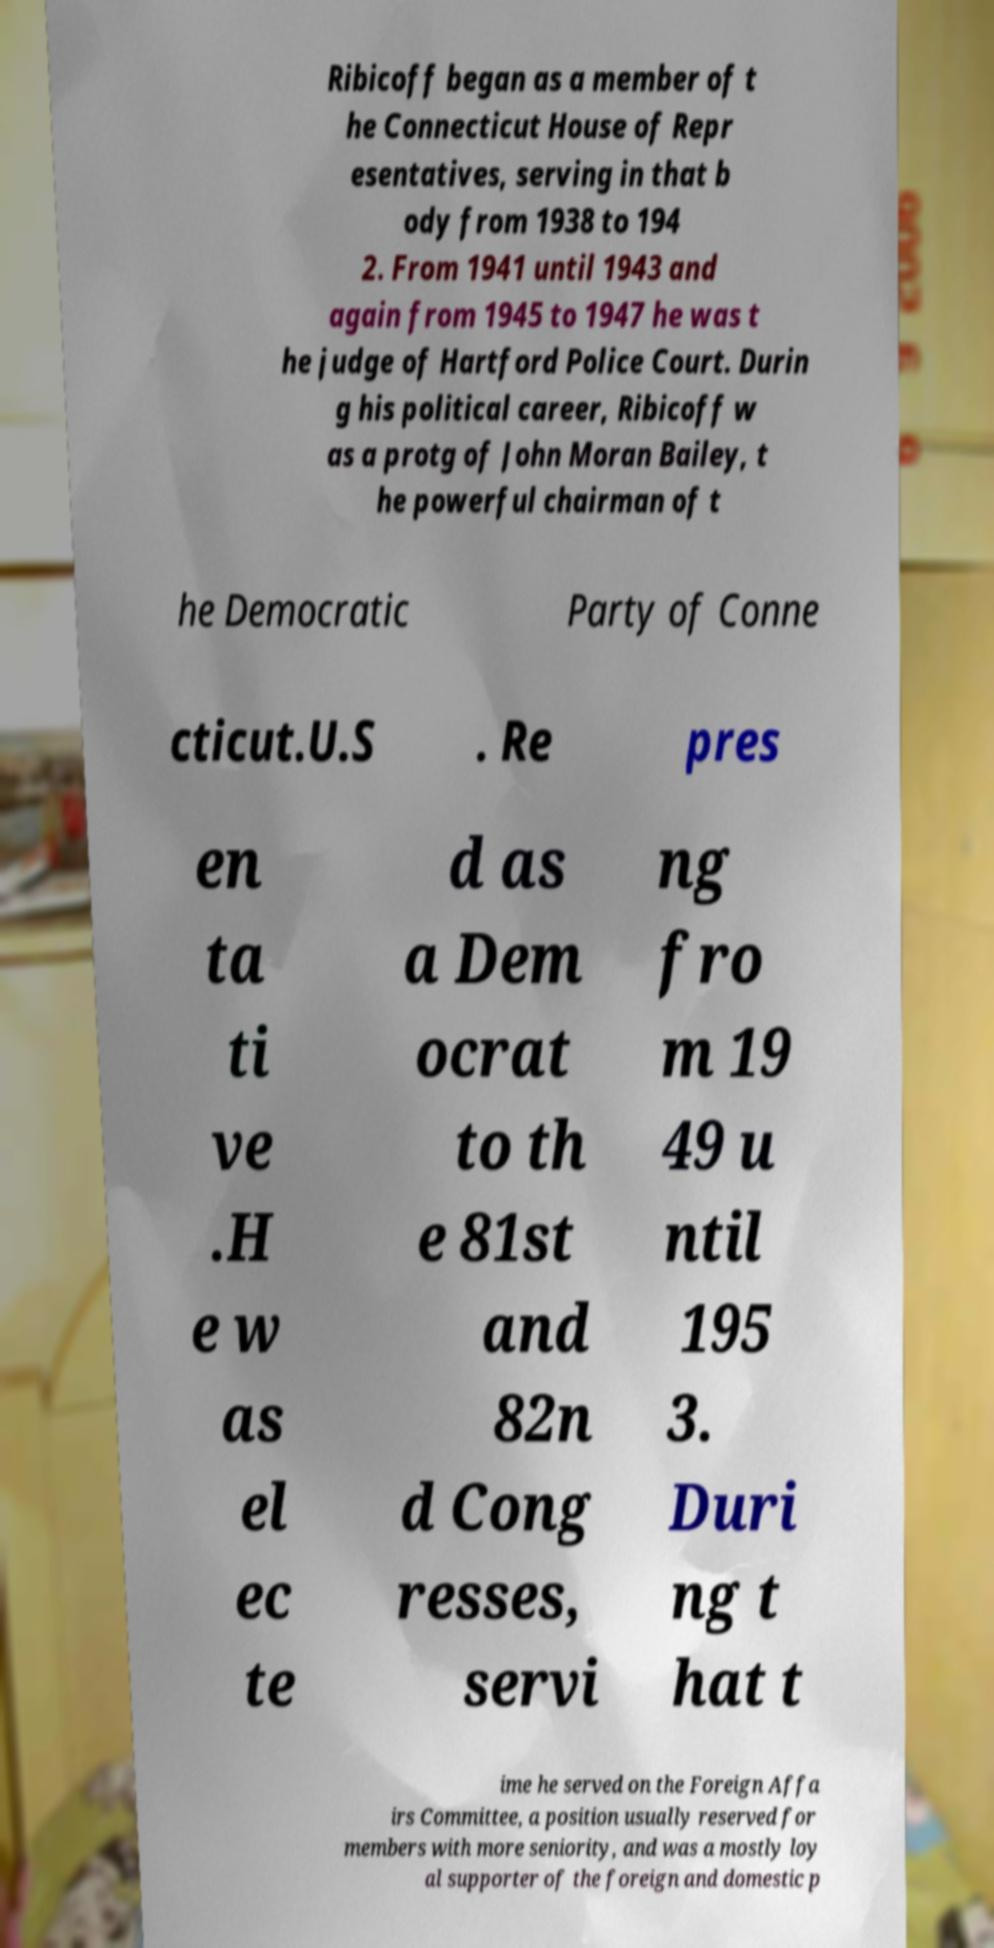Please read and relay the text visible in this image. What does it say? Ribicoff began as a member of t he Connecticut House of Repr esentatives, serving in that b ody from 1938 to 194 2. From 1941 until 1943 and again from 1945 to 1947 he was t he judge of Hartford Police Court. Durin g his political career, Ribicoff w as a protg of John Moran Bailey, t he powerful chairman of t he Democratic Party of Conne cticut.U.S . Re pres en ta ti ve .H e w as el ec te d as a Dem ocrat to th e 81st and 82n d Cong resses, servi ng fro m 19 49 u ntil 195 3. Duri ng t hat t ime he served on the Foreign Affa irs Committee, a position usually reserved for members with more seniority, and was a mostly loy al supporter of the foreign and domestic p 